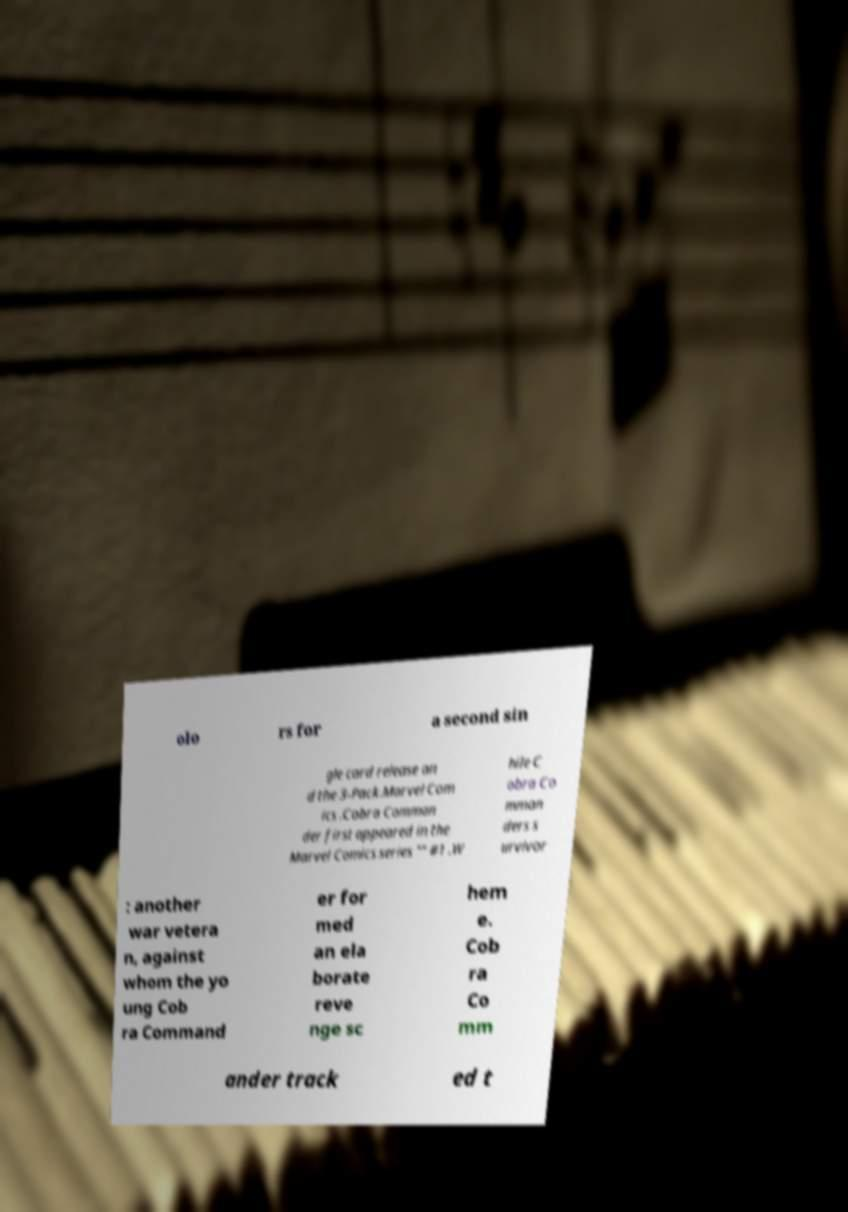I need the written content from this picture converted into text. Can you do that? olo rs for a second sin gle card release an d the 3-Pack.Marvel Com ics .Cobra Comman der first appeared in the Marvel Comics series "" #1 .W hile C obra Co mman ders s urvivor : another war vetera n, against whom the yo ung Cob ra Command er for med an ela borate reve nge sc hem e. Cob ra Co mm ander track ed t 